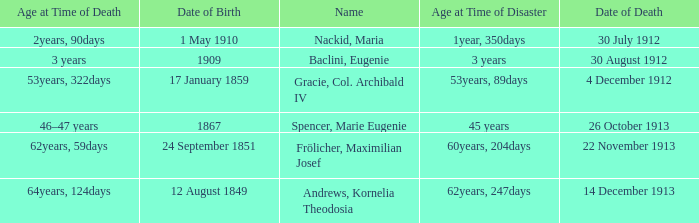How old was the person born 24 September 1851 at the time of disaster? 60years, 204days. 